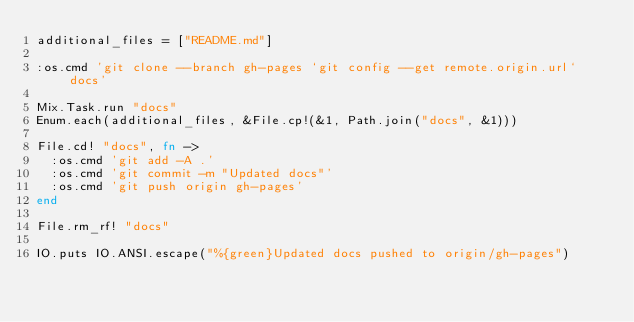<code> <loc_0><loc_0><loc_500><loc_500><_Elixir_>additional_files = ["README.md"]

:os.cmd 'git clone --branch gh-pages `git config --get remote.origin.url` docs'

Mix.Task.run "docs"
Enum.each(additional_files, &File.cp!(&1, Path.join("docs", &1)))

File.cd! "docs", fn ->
  :os.cmd 'git add -A .'
  :os.cmd 'git commit -m "Updated docs"'
  :os.cmd 'git push origin gh-pages'
end

File.rm_rf! "docs"

IO.puts IO.ANSI.escape("%{green}Updated docs pushed to origin/gh-pages")
</code> 